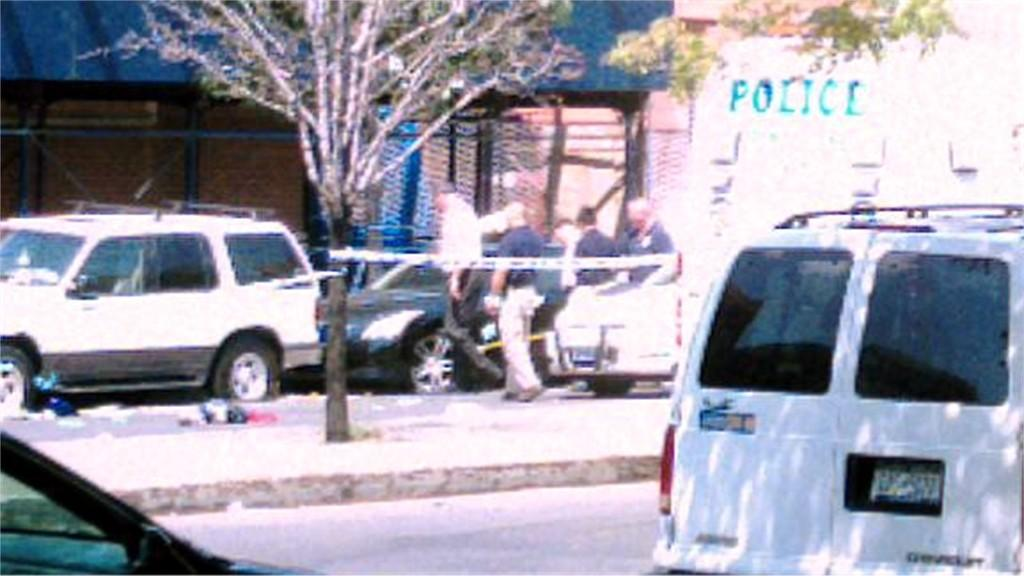<image>
Share a concise interpretation of the image provided. A white van is parked by an even larger van that says Police on the back. 